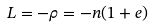Convert formula to latex. <formula><loc_0><loc_0><loc_500><loc_500>L = - \rho = - n ( 1 + e )</formula> 